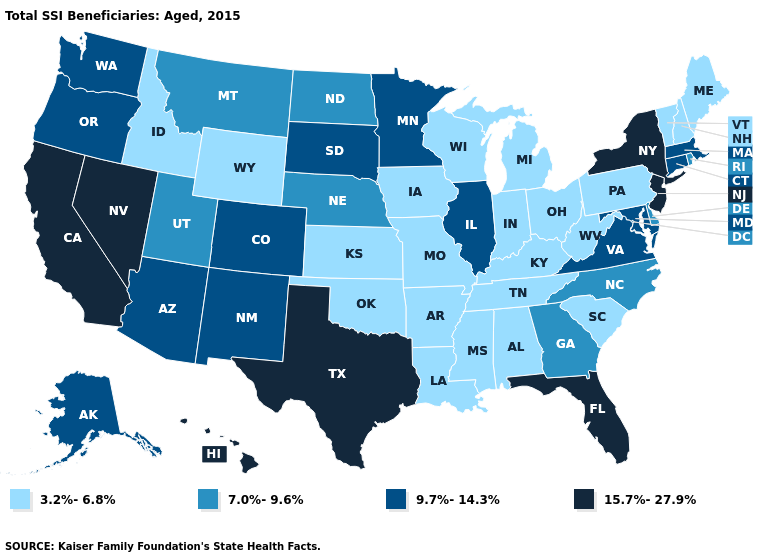What is the value of Kentucky?
Short answer required. 3.2%-6.8%. What is the lowest value in the Northeast?
Be succinct. 3.2%-6.8%. Does the map have missing data?
Short answer required. No. Does the map have missing data?
Short answer required. No. Does the map have missing data?
Write a very short answer. No. Name the states that have a value in the range 7.0%-9.6%?
Give a very brief answer. Delaware, Georgia, Montana, Nebraska, North Carolina, North Dakota, Rhode Island, Utah. What is the value of Wyoming?
Write a very short answer. 3.2%-6.8%. Name the states that have a value in the range 7.0%-9.6%?
Keep it brief. Delaware, Georgia, Montana, Nebraska, North Carolina, North Dakota, Rhode Island, Utah. Which states hav the highest value in the South?
Answer briefly. Florida, Texas. Does Rhode Island have the lowest value in the Northeast?
Answer briefly. No. Does the first symbol in the legend represent the smallest category?
Be succinct. Yes. Does Rhode Island have the lowest value in the Northeast?
Give a very brief answer. No. Which states have the lowest value in the USA?
Quick response, please. Alabama, Arkansas, Idaho, Indiana, Iowa, Kansas, Kentucky, Louisiana, Maine, Michigan, Mississippi, Missouri, New Hampshire, Ohio, Oklahoma, Pennsylvania, South Carolina, Tennessee, Vermont, West Virginia, Wisconsin, Wyoming. Does Missouri have the highest value in the MidWest?
Keep it brief. No. Does Pennsylvania have a lower value than Mississippi?
Keep it brief. No. 